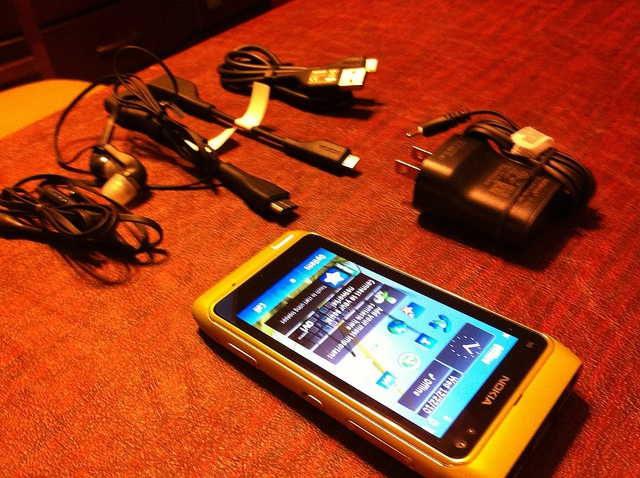Describe the objects in this image and their specific colors. I can see cell phone in black, white, orange, and maroon tones and chair in black and maroon tones in this image. 